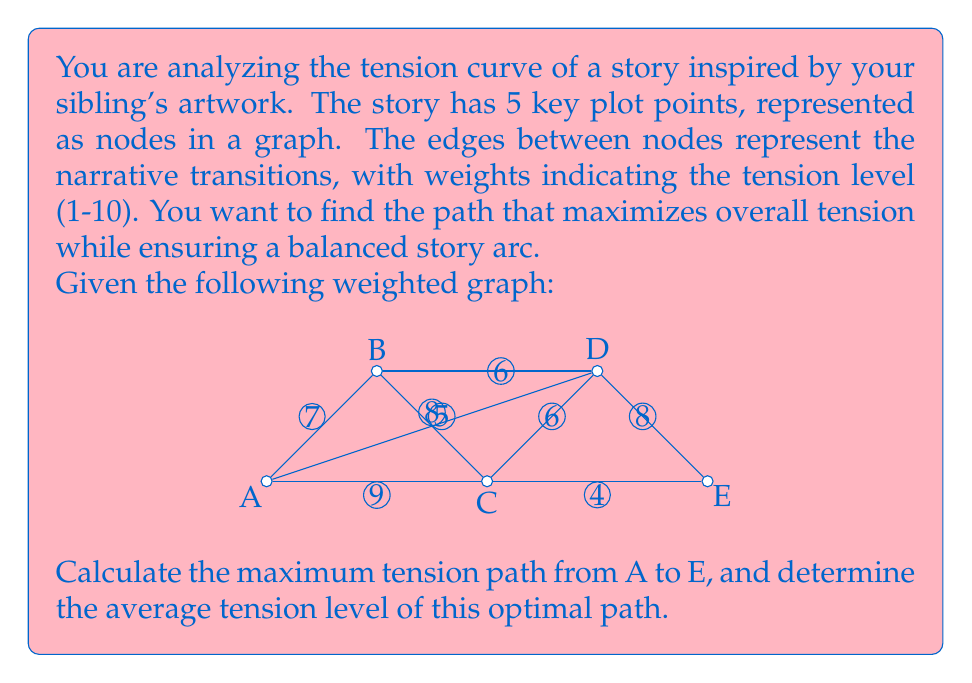Provide a solution to this math problem. To solve this problem, we'll use Dijkstra's algorithm to find the path with the maximum total tension, rather than the typical minimum path. We'll then calculate the average tension of this path.

Step 1: Set up the adjacency matrix for the graph.
$$
\begin{bmatrix}
0 & 7 & 9 & 8 & 0 \\
7 & 0 & 5 & 6 & 0 \\
9 & 5 & 0 & 6 & 4 \\
8 & 6 & 6 & 0 & 8 \\
0 & 0 & 4 & 8 & 0
\end{bmatrix}
$$

Step 2: Apply Dijkstra's algorithm (modified for maximum path):
1. Start at A, mark tension 0, others ∞
2. Update neighbors of A: B(7), C(9), D(8)
3. Select C (highest tension), mark as visited
4. Update neighbors of C: B(9), D(15), E(13)
5. Select D (highest unvisited), mark as visited
6. Update neighbors of D: B(15), E(23)
7. Select E (highest unvisited), algorithm complete

The maximum tension path is A → C → D → E with a total tension of 23.

Step 3: Calculate the average tension
- Number of edges in the path = 3
- Average tension = Total tension / Number of edges
- Average tension = 23 / 3 ≈ 7.67
Answer: The maximum tension path is A → C → D → E with a total tension of 23 and an average tension of approximately 7.67. 